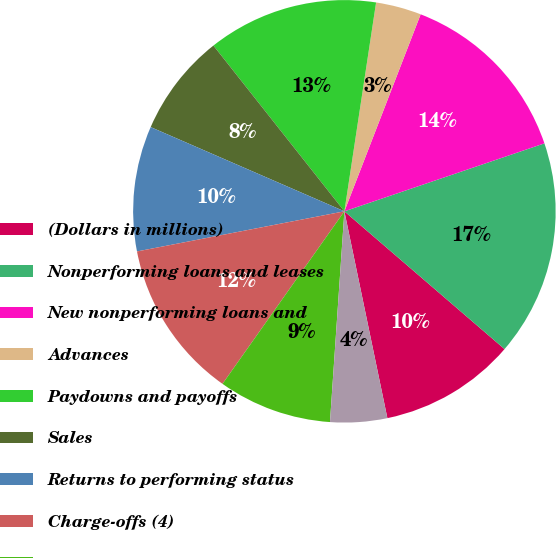Convert chart to OTSL. <chart><loc_0><loc_0><loc_500><loc_500><pie_chart><fcel>(Dollars in millions)<fcel>Nonperforming loans and leases<fcel>New nonperforming loans and<fcel>Advances<fcel>Paydowns and payoffs<fcel>Sales<fcel>Returns to performing status<fcel>Charge-offs (4)<fcel>Transfers to foreclosed<fcel>Transfers to loans<nl><fcel>10.43%<fcel>16.52%<fcel>13.91%<fcel>3.48%<fcel>13.04%<fcel>7.83%<fcel>9.57%<fcel>12.17%<fcel>8.7%<fcel>4.35%<nl></chart> 